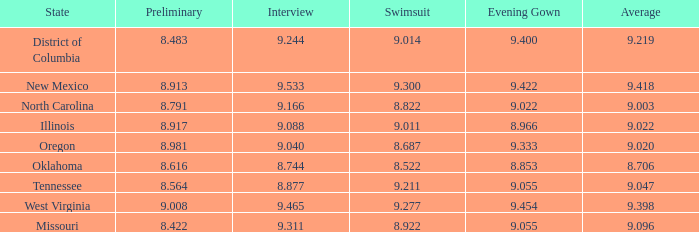Name the preliminary for north carolina 8.791. 